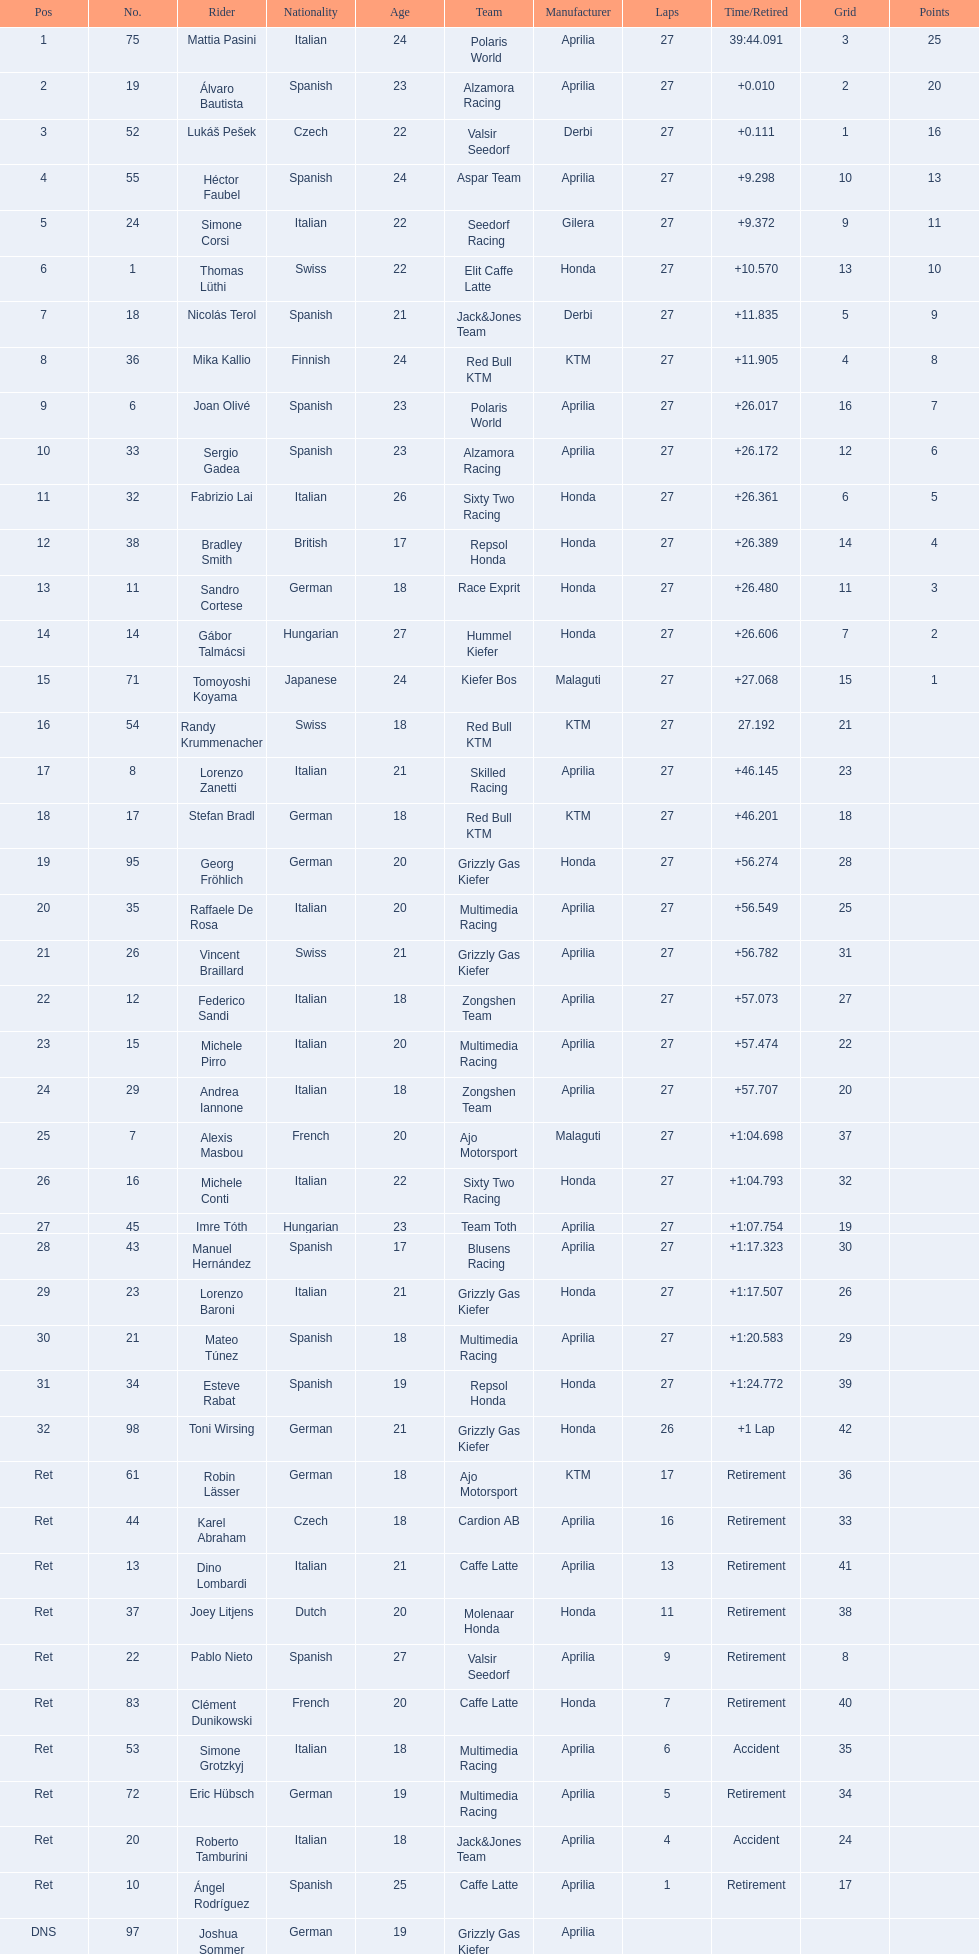How many racers did not use an aprilia or a honda? 9. 